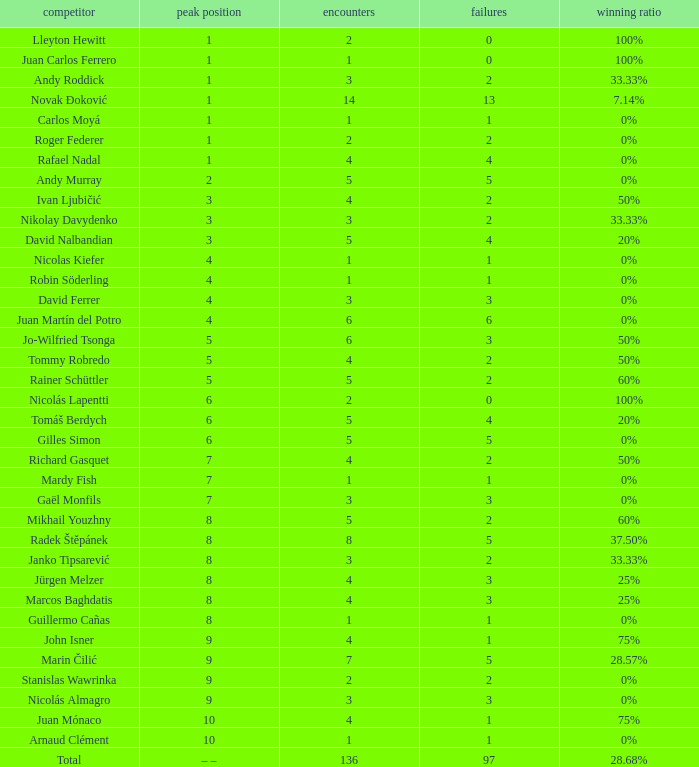What is the smallest number of Matches with less than 97 losses and a Win rate of 28.68%? None. 